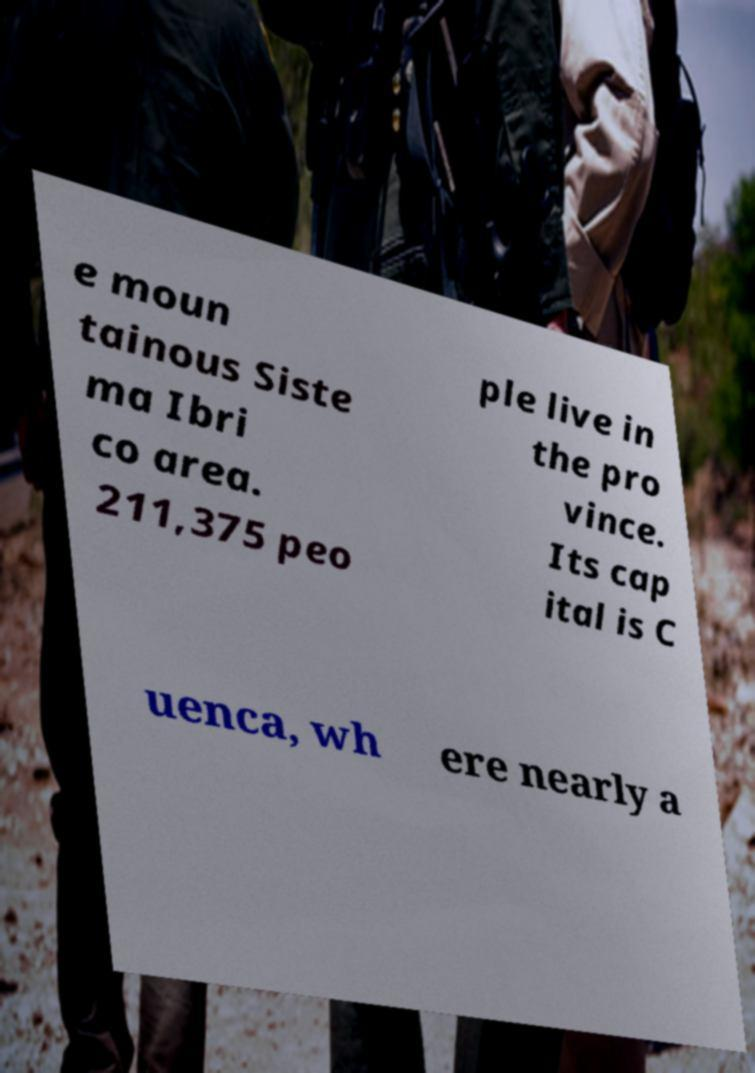What messages or text are displayed in this image? I need them in a readable, typed format. e moun tainous Siste ma Ibri co area. 211,375 peo ple live in the pro vince. Its cap ital is C uenca, wh ere nearly a 